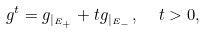<formula> <loc_0><loc_0><loc_500><loc_500>g ^ { t } = g _ { | _ { E _ { + } } } + t g _ { | _ { E _ { - } } } , \ \ t > 0 ,</formula> 